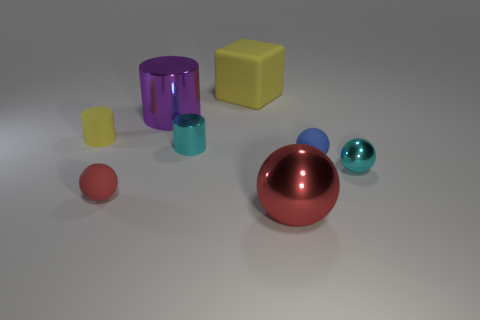Is the color of the tiny metallic ball the same as the tiny shiny cylinder?
Your response must be concise. Yes. How many objects are big red shiny objects or cyan objects?
Your answer should be very brief. 3. Are there any other objects of the same shape as the small red matte object?
Offer a terse response. Yes. There is a rubber ball that is to the left of the large red metallic thing; is its color the same as the big shiny sphere?
Provide a succinct answer. Yes. The small rubber object that is on the right side of the yellow rubber object to the right of the small red matte object is what shape?
Your response must be concise. Sphere. Is there a red sphere that has the same size as the yellow cylinder?
Provide a succinct answer. Yes. Is the number of small brown things less than the number of tiny cylinders?
Offer a terse response. Yes. What shape is the red rubber thing that is to the left of the small cyan object that is left of the cyan metal object that is on the right side of the tiny blue rubber ball?
Provide a succinct answer. Sphere. What number of things are tiny cyan objects that are on the right side of the small blue ball or yellow rubber things to the right of the purple shiny thing?
Make the answer very short. 2. There is a tiny cyan metal cylinder; are there any small rubber things behind it?
Offer a terse response. Yes. 